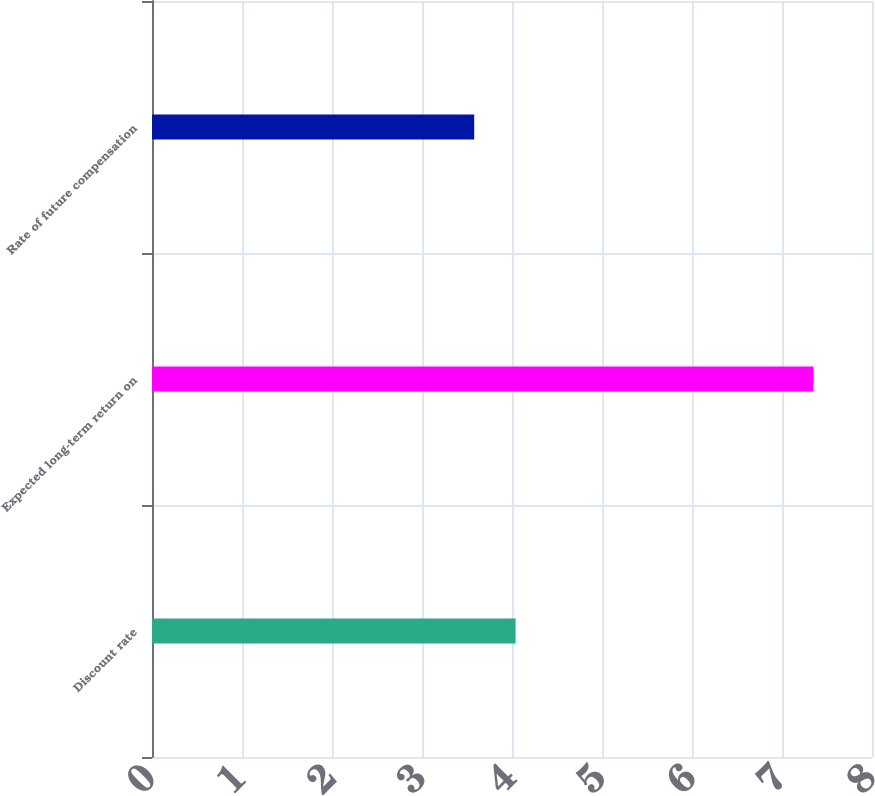Convert chart to OTSL. <chart><loc_0><loc_0><loc_500><loc_500><bar_chart><fcel>Discount rate<fcel>Expected long-term return on<fcel>Rate of future compensation<nl><fcel>4.04<fcel>7.35<fcel>3.58<nl></chart> 